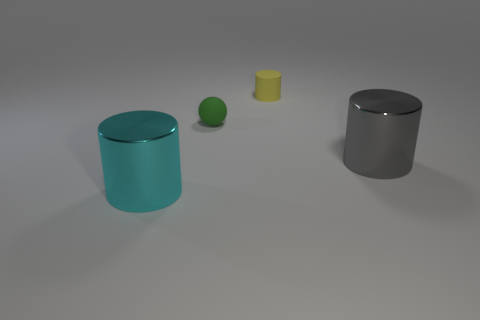Add 2 tiny yellow matte things. How many objects exist? 6 Subtract all spheres. How many objects are left? 3 Subtract 0 purple blocks. How many objects are left? 4 Subtract all small green rubber things. Subtract all red balls. How many objects are left? 3 Add 1 green balls. How many green balls are left? 2 Add 1 small cyan matte cylinders. How many small cyan matte cylinders exist? 1 